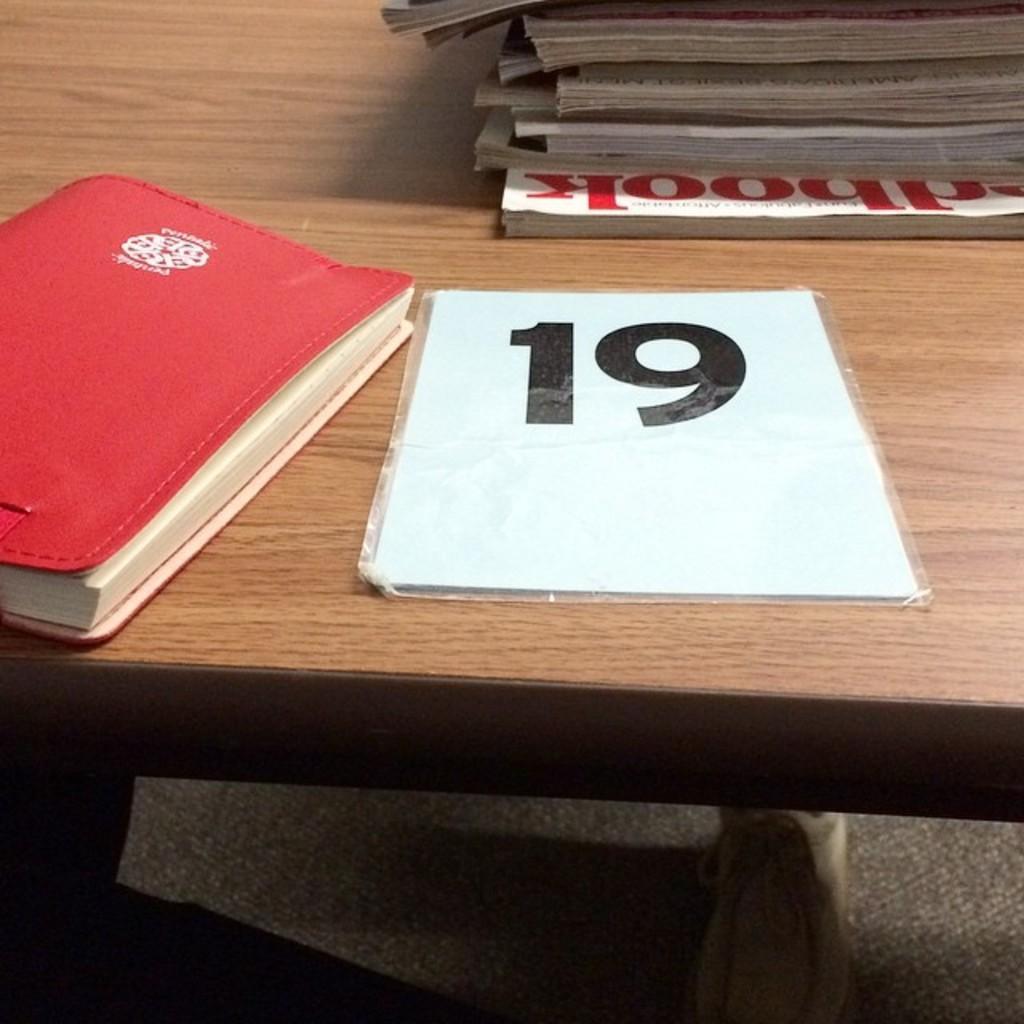Could you give a brief overview of what you see in this image? In this picture I can see few books on a table. 